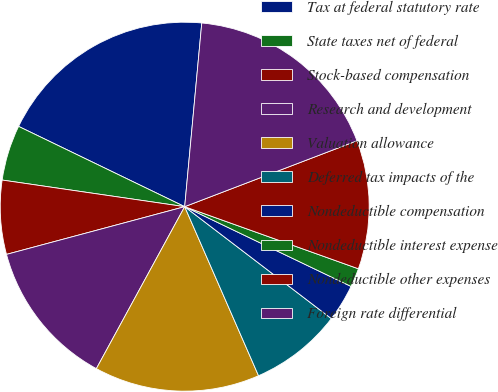<chart> <loc_0><loc_0><loc_500><loc_500><pie_chart><fcel>Tax at federal statutory rate<fcel>State taxes net of federal<fcel>Stock-based compensation<fcel>Research and development<fcel>Valuation allowance<fcel>Deferred tax impacts of the<fcel>Nondeductible compensation<fcel>Nondeductible interest expense<fcel>Nondeductible other expenses<fcel>Foreign rate differential<nl><fcel>19.31%<fcel>4.86%<fcel>6.47%<fcel>12.89%<fcel>14.5%<fcel>8.07%<fcel>3.26%<fcel>1.65%<fcel>11.28%<fcel>17.71%<nl></chart> 